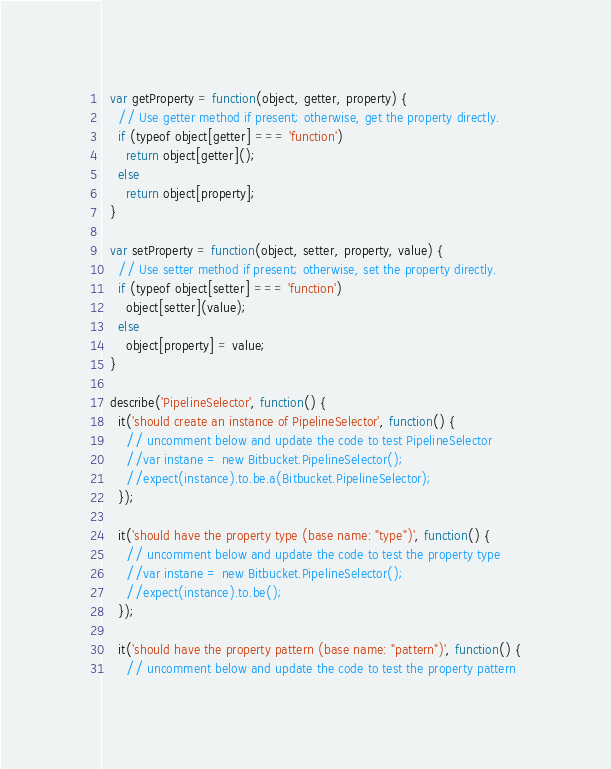Convert code to text. <code><loc_0><loc_0><loc_500><loc_500><_JavaScript_>  var getProperty = function(object, getter, property) {
    // Use getter method if present; otherwise, get the property directly.
    if (typeof object[getter] === 'function')
      return object[getter]();
    else
      return object[property];
  }

  var setProperty = function(object, setter, property, value) {
    // Use setter method if present; otherwise, set the property directly.
    if (typeof object[setter] === 'function')
      object[setter](value);
    else
      object[property] = value;
  }

  describe('PipelineSelector', function() {
    it('should create an instance of PipelineSelector', function() {
      // uncomment below and update the code to test PipelineSelector
      //var instane = new Bitbucket.PipelineSelector();
      //expect(instance).to.be.a(Bitbucket.PipelineSelector);
    });

    it('should have the property type (base name: "type")', function() {
      // uncomment below and update the code to test the property type
      //var instane = new Bitbucket.PipelineSelector();
      //expect(instance).to.be();
    });

    it('should have the property pattern (base name: "pattern")', function() {
      // uncomment below and update the code to test the property pattern</code> 